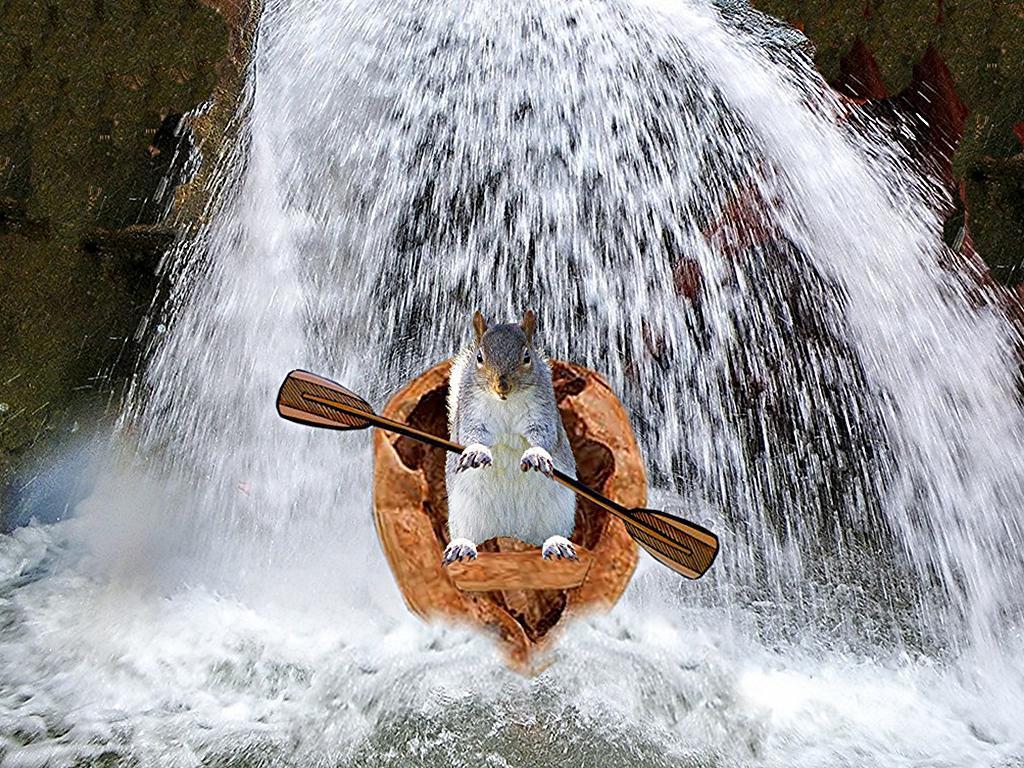Describe this image in one or two sentences. In the picture I can see a squirrel in the boat and the squirrel is holding the boat oars. In the background, I can see the waterfall. 